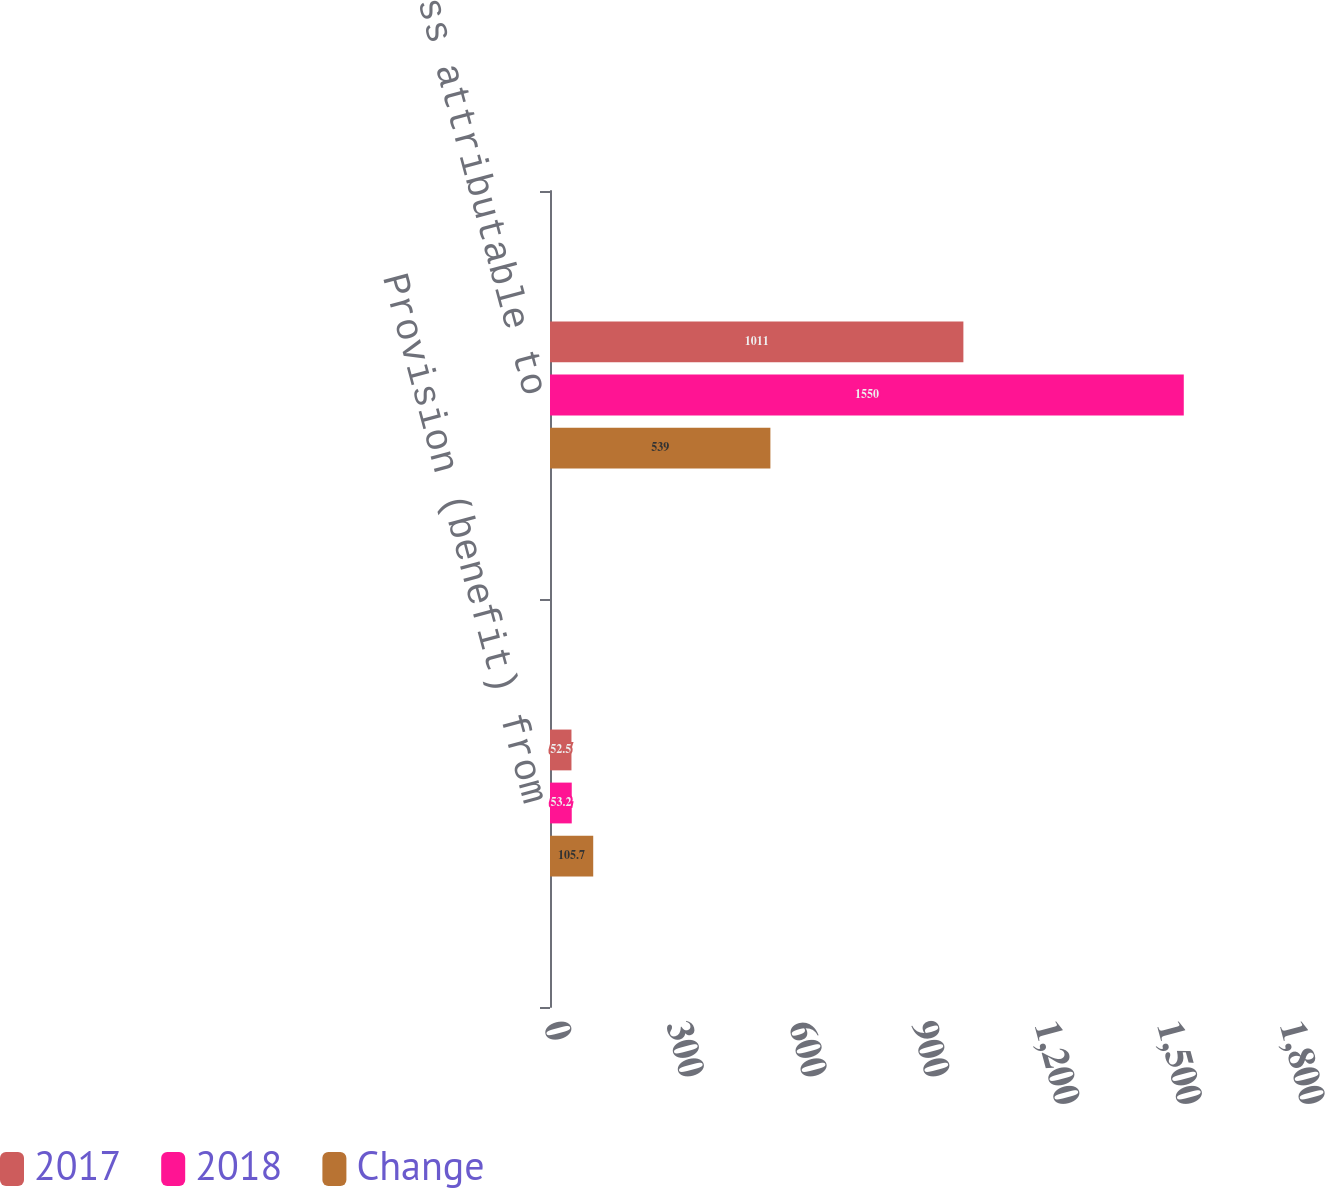Convert chart to OTSL. <chart><loc_0><loc_0><loc_500><loc_500><stacked_bar_chart><ecel><fcel>Provision (benefit) from<fcel>Net loss attributable to<nl><fcel>2017<fcel>52.5<fcel>1011<nl><fcel>2018<fcel>53.2<fcel>1550<nl><fcel>Change<fcel>105.7<fcel>539<nl></chart> 